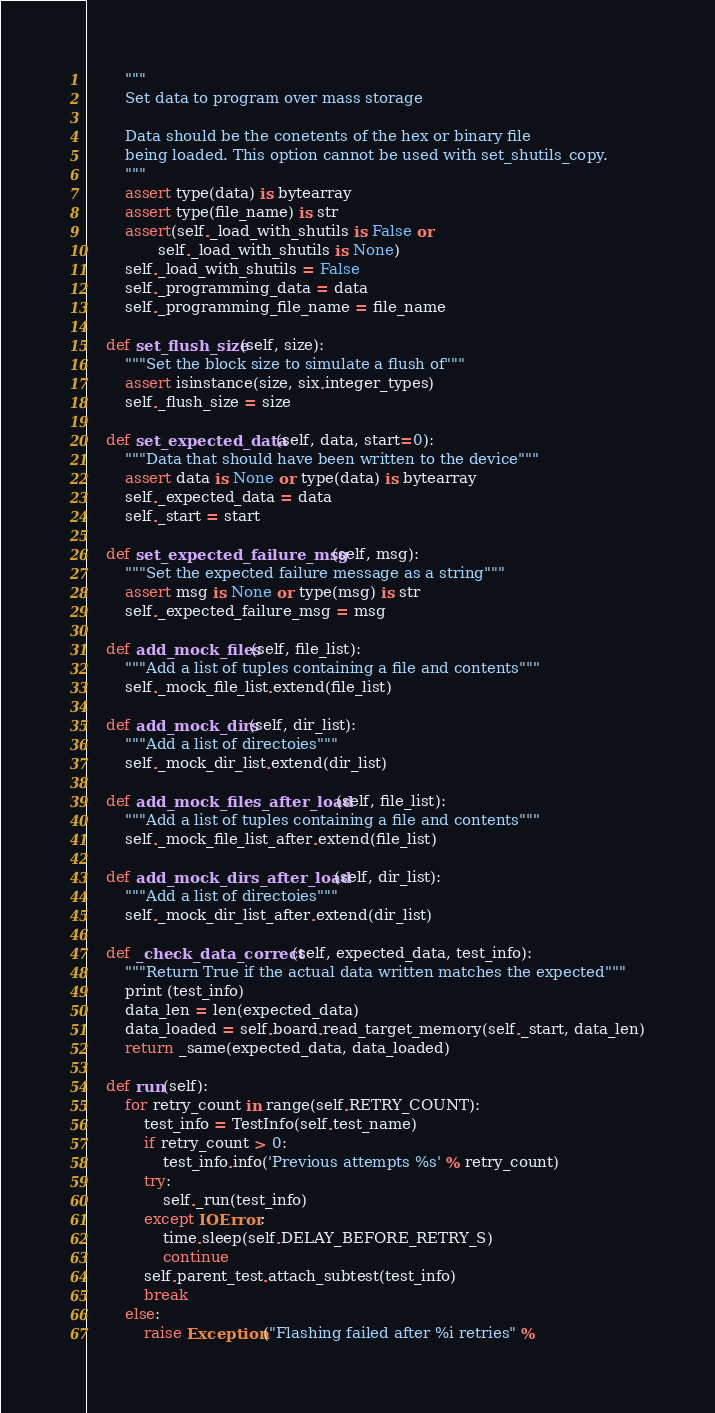Convert code to text. <code><loc_0><loc_0><loc_500><loc_500><_Python_>        """
        Set data to program over mass storage

        Data should be the conetents of the hex or binary file
        being loaded. This option cannot be used with set_shutils_copy.
        """
        assert type(data) is bytearray
        assert type(file_name) is str
        assert(self._load_with_shutils is False or
               self._load_with_shutils is None)
        self._load_with_shutils = False
        self._programming_data = data
        self._programming_file_name = file_name

    def set_flush_size(self, size):
        """Set the block size to simulate a flush of"""
        assert isinstance(size, six.integer_types)
        self._flush_size = size

    def set_expected_data(self, data, start=0):
        """Data that should have been written to the device"""
        assert data is None or type(data) is bytearray
        self._expected_data = data
        self._start = start

    def set_expected_failure_msg(self, msg):
        """Set the expected failure message as a string"""
        assert msg is None or type(msg) is str
        self._expected_failure_msg = msg

    def add_mock_files(self, file_list):
        """Add a list of tuples containing a file and contents"""
        self._mock_file_list.extend(file_list)

    def add_mock_dirs(self, dir_list):
        """Add a list of directoies"""
        self._mock_dir_list.extend(dir_list)

    def add_mock_files_after_load(self, file_list):
        """Add a list of tuples containing a file and contents"""
        self._mock_file_list_after.extend(file_list)

    def add_mock_dirs_after_load(self, dir_list):
        """Add a list of directoies"""
        self._mock_dir_list_after.extend(dir_list)

    def _check_data_correct(self, expected_data, test_info):
        """Return True if the actual data written matches the expected"""
        print (test_info)
        data_len = len(expected_data)
        data_loaded = self.board.read_target_memory(self._start, data_len)
        return _same(expected_data, data_loaded)

    def run(self):
        for retry_count in range(self.RETRY_COUNT):
            test_info = TestInfo(self.test_name)
            if retry_count > 0:
                test_info.info('Previous attempts %s' % retry_count)
            try:
                self._run(test_info)
            except IOError:
                time.sleep(self.DELAY_BEFORE_RETRY_S)
                continue
            self.parent_test.attach_subtest(test_info)
            break
        else:
            raise Exception("Flashing failed after %i retries" %</code> 